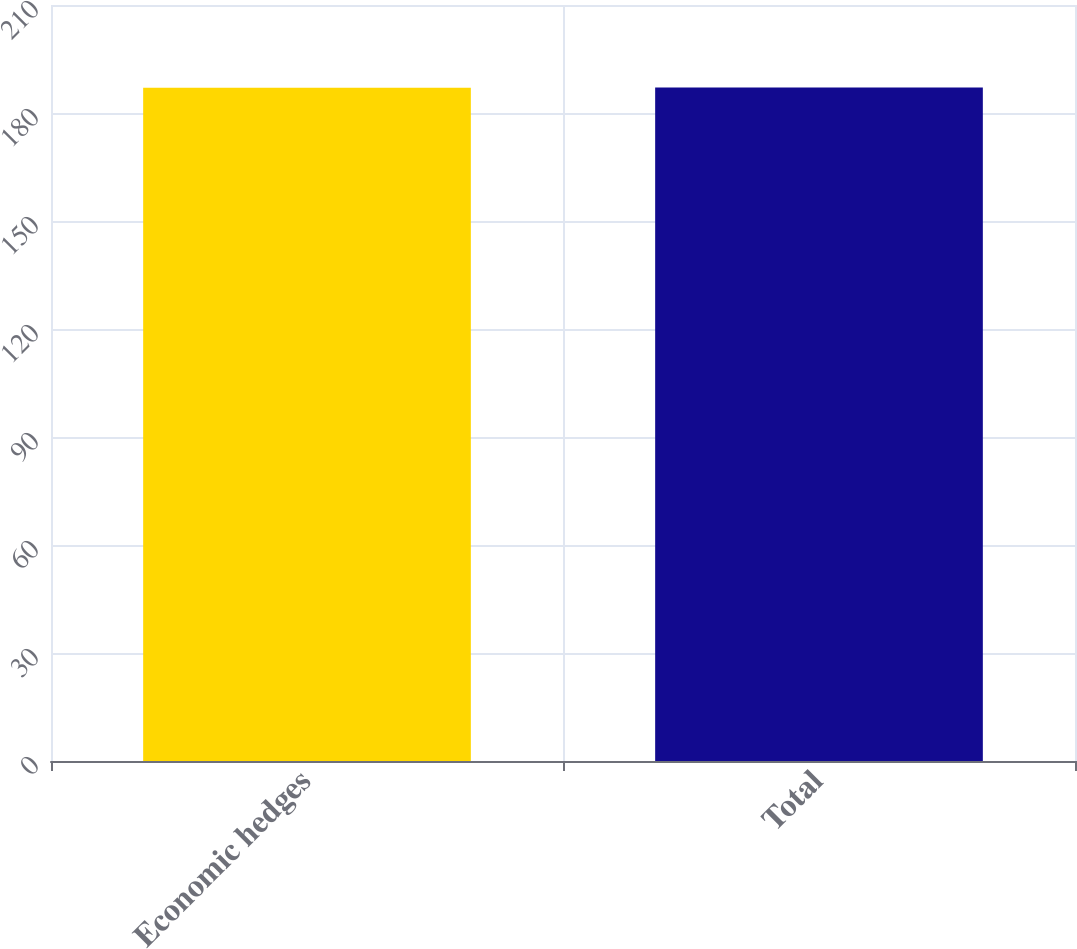Convert chart to OTSL. <chart><loc_0><loc_0><loc_500><loc_500><bar_chart><fcel>Economic hedges<fcel>Total<nl><fcel>187<fcel>187.1<nl></chart> 